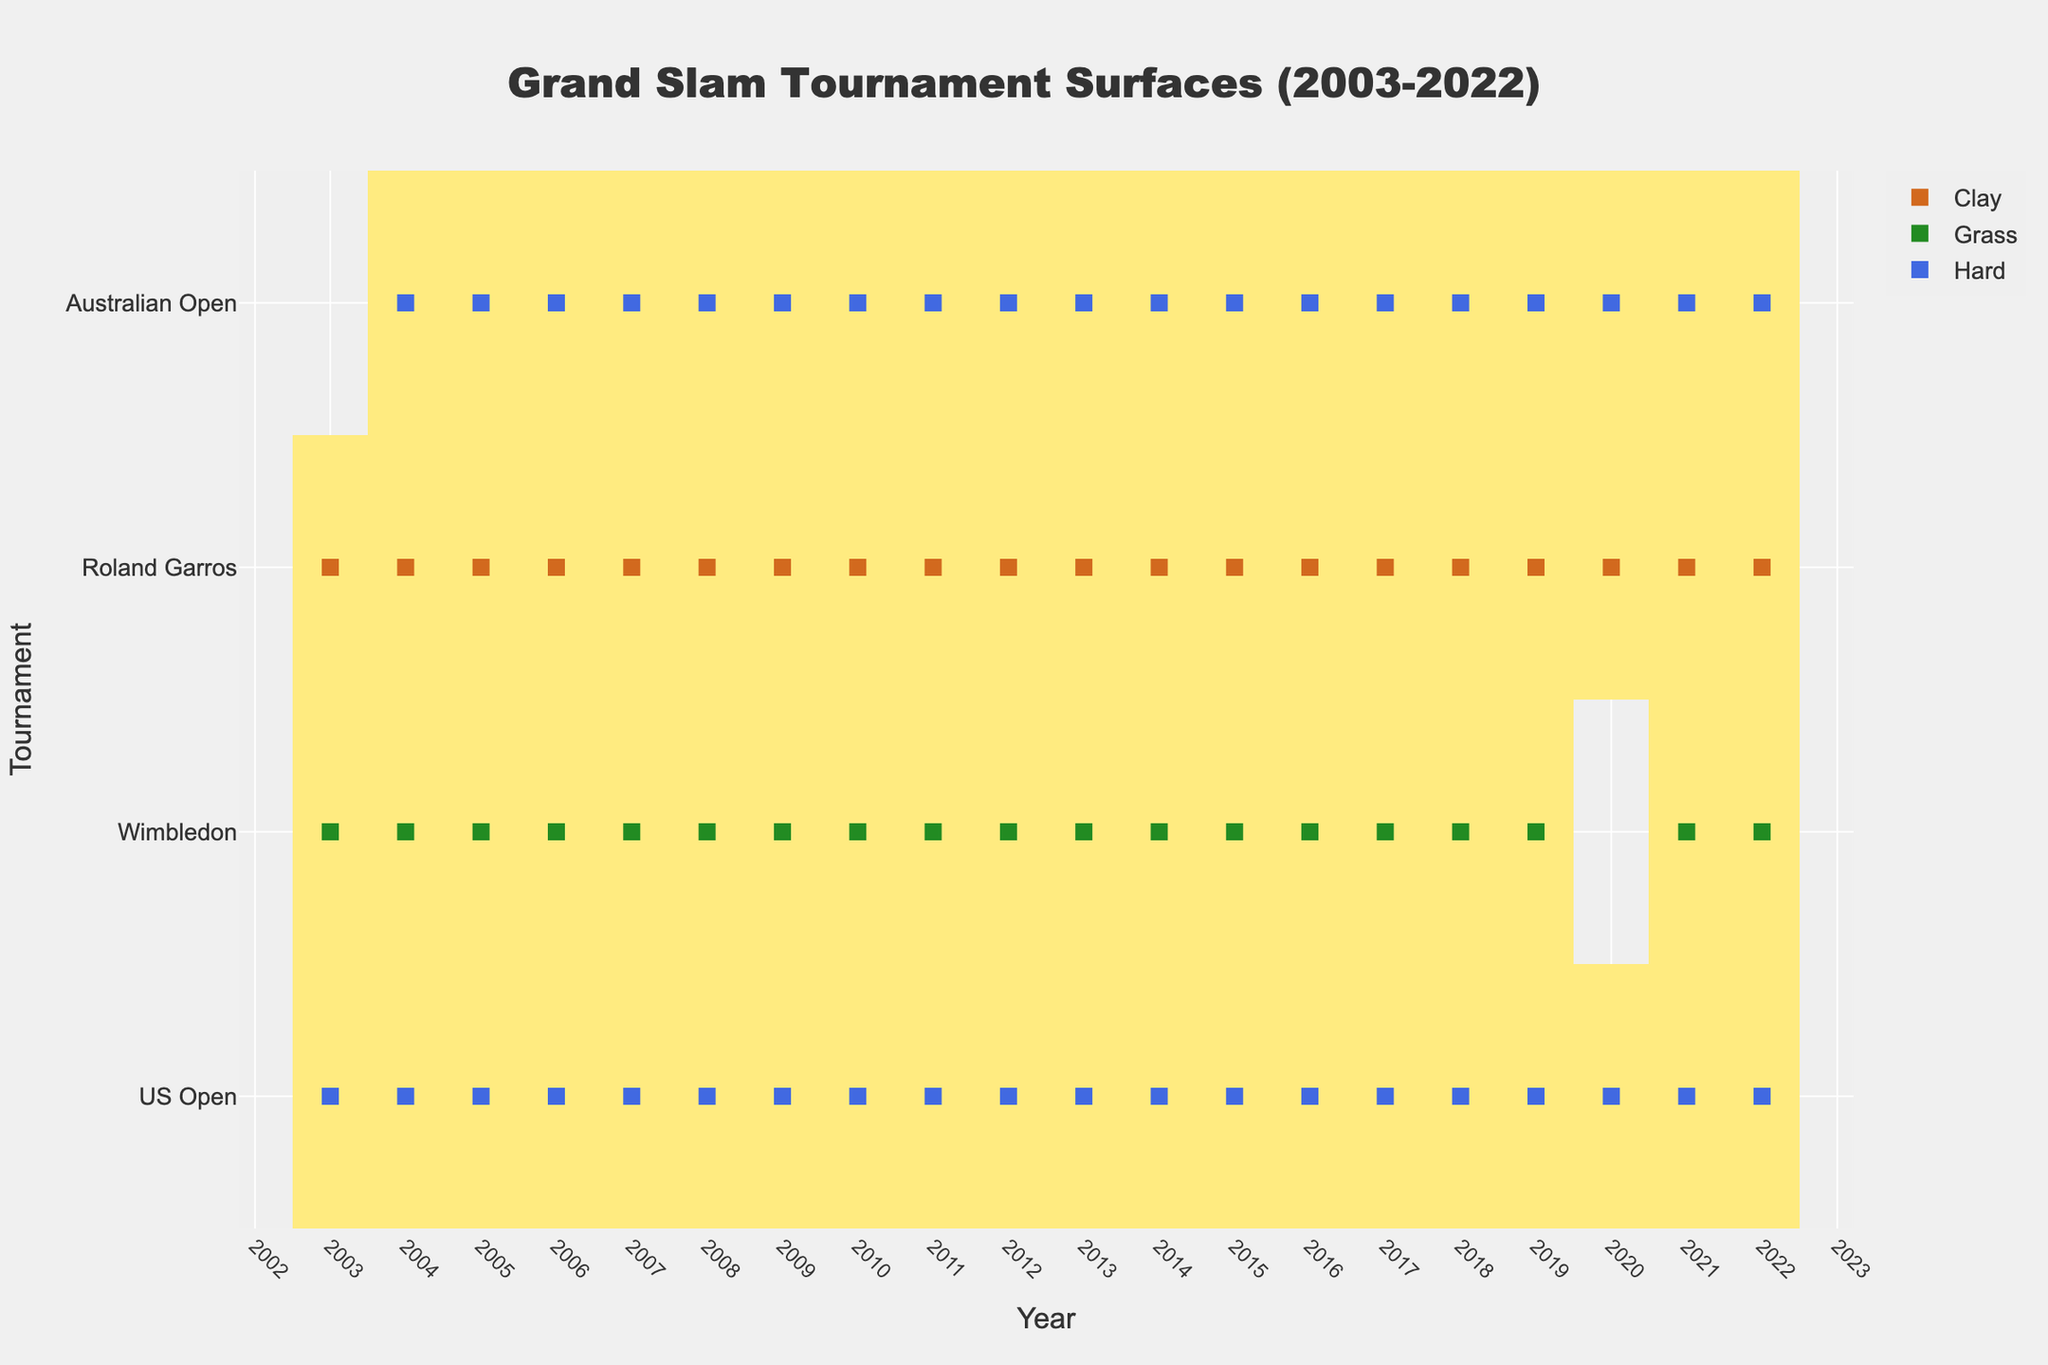What's the title of the heatmap? The title is usually displayed at the top center of a plot. In this case, the title is "Grand Slam Tournament Surfaces (2003-2022)."
Answer: Grand Slam Tournament Surfaces (2003-2022) What surfaces are indicated in the heatmap? The surfaces are indicated by different colors in the legend. The surfaces used are Clay, Grass, Hard, and Carpet.
Answer: Clay, Grass, Hard, Carpet How many tournaments are represented in the heatmap? The tournaments are represented on the y-axis. By counting the distinct labels, there are 4 tournaments: US Open, Wimbledon, Roland Garros, Australian Open.
Answer: 4 How many years does the heatmap cover? The years are represented on the x-axis. By counting the range from start to end, the heatmap covers 2022 - 2003 + 1 = 20 years from 2003 to 2022.
Answer: 20 Which surface is the most frequently used in the Australian Open? Each surface is color-coded and appears as markers in the heatmap. By visually scanning the Australian Open row, the Hard surface (blue markers) is the most frequent.
Answer: Hard How many times was the French tournament (Roland Garros) played on clay in these 20 years? By checking the Roland Garros row and noting the frequency of Clay surface markers (brown), it's played on clay every year over the 20 years.
Answer: 20 times Between Wimbledon and US Open, which tournament has more variety in surface types? By scanning the rows for Wimbledon and US Open, only Wimbledon shows multiple surface types (Grass and Grass); US Open remains constant with Hard courts.
Answer: Wimbledon In what year did Wimbledon not take place, according to the heatmap? Look at the Wimbledon row for any missing data points. Wimbledon did not take place in 2020 (no marker for that year).
Answer: 2020 Looking at the heatmap, which tournament shows the least diversity in court surfaces? By evaluating the variety of surface markers for each tournament row, Roland Garros consistently uses only one type (Clay).
Answer: Roland Garros How many times did the Wimbledon tournament switch its surface? By comparing the Wimbledon row markers, it is clear they never switched surfaces during these years (remains the same).
Answer: 0 times 